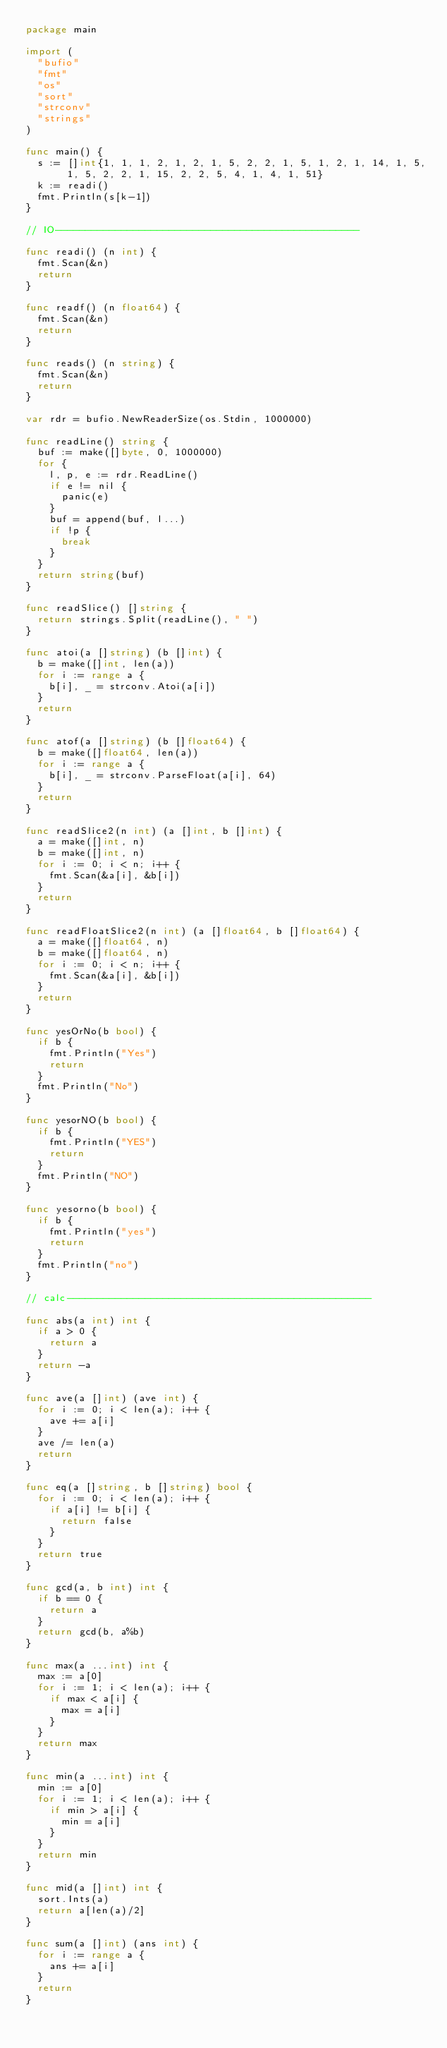Convert code to text. <code><loc_0><loc_0><loc_500><loc_500><_Go_>package main

import (
	"bufio"
	"fmt"
	"os"
	"sort"
	"strconv"
	"strings"
)

func main() {
	s := []int{1, 1, 1, 2, 1, 2, 1, 5, 2, 2, 1, 5, 1, 2, 1, 14, 1, 5, 1, 5, 2, 2, 1, 15, 2, 2, 5, 4, 1, 4, 1, 51}
	k := readi()
	fmt.Println(s[k-1])
}

// IO---------------------------------------------------

func readi() (n int) {
	fmt.Scan(&n)
	return
}

func readf() (n float64) {
	fmt.Scan(&n)
	return
}

func reads() (n string) {
	fmt.Scan(&n)
	return
}

var rdr = bufio.NewReaderSize(os.Stdin, 1000000)

func readLine() string {
	buf := make([]byte, 0, 1000000)
	for {
		l, p, e := rdr.ReadLine()
		if e != nil {
			panic(e)
		}
		buf = append(buf, l...)
		if !p {
			break
		}
	}
	return string(buf)
}

func readSlice() []string {
	return strings.Split(readLine(), " ")
}

func atoi(a []string) (b []int) {
	b = make([]int, len(a))
	for i := range a {
		b[i], _ = strconv.Atoi(a[i])
	}
	return
}

func atof(a []string) (b []float64) {
	b = make([]float64, len(a))
	for i := range a {
		b[i], _ = strconv.ParseFloat(a[i], 64)
	}
	return
}

func readSlice2(n int) (a []int, b []int) {
	a = make([]int, n)
	b = make([]int, n)
	for i := 0; i < n; i++ {
		fmt.Scan(&a[i], &b[i])
	}
	return
}

func readFloatSlice2(n int) (a []float64, b []float64) {
	a = make([]float64, n)
	b = make([]float64, n)
	for i := 0; i < n; i++ {
		fmt.Scan(&a[i], &b[i])
	}
	return
}

func yesOrNo(b bool) {
	if b {
		fmt.Println("Yes")
		return
	}
	fmt.Println("No")
}

func yesorNO(b bool) {
	if b {
		fmt.Println("YES")
		return
	}
	fmt.Println("NO")
}

func yesorno(b bool) {
	if b {
		fmt.Println("yes")
		return
	}
	fmt.Println("no")
}

// calc---------------------------------------------------

func abs(a int) int {
	if a > 0 {
		return a
	}
	return -a
}

func ave(a []int) (ave int) {
	for i := 0; i < len(a); i++ {
		ave += a[i]
	}
	ave /= len(a)
	return
}

func eq(a []string, b []string) bool {
	for i := 0; i < len(a); i++ {
		if a[i] != b[i] {
			return false
		}
	}
	return true
}

func gcd(a, b int) int {
	if b == 0 {
		return a
	}
	return gcd(b, a%b)
}

func max(a ...int) int {
	max := a[0]
	for i := 1; i < len(a); i++ {
		if max < a[i] {
			max = a[i]
		}
	}
	return max
}

func min(a ...int) int {
	min := a[0]
	for i := 1; i < len(a); i++ {
		if min > a[i] {
			min = a[i]
		}
	}
	return min
}

func mid(a []int) int {
	sort.Ints(a)
	return a[len(a)/2]
}

func sum(a []int) (ans int) {
	for i := range a {
		ans += a[i]
	}
	return
}</code> 